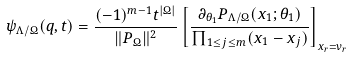Convert formula to latex. <formula><loc_0><loc_0><loc_500><loc_500>\psi _ { \Lambda / \Omega } ( q , t ) = \frac { ( - 1 ) ^ { m - 1 } t ^ { | \Omega | } } { \| P _ { \Omega } \| ^ { 2 } } \left [ \frac { \partial _ { \theta _ { 1 } } P _ { \Lambda / \Omega } ( x _ { 1 } ; \theta _ { 1 } ) } { \prod _ { 1 \leq j \leq m } ( x _ { 1 } - x _ { j } ) } \right ] _ { x _ { r } = v _ { r } }</formula> 